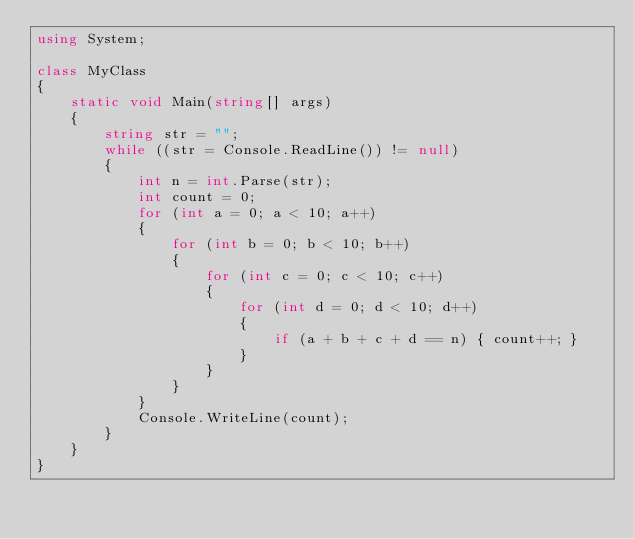<code> <loc_0><loc_0><loc_500><loc_500><_C#_>using System;

class MyClass
{
    static void Main(string[] args)
    {
        string str = "";
        while ((str = Console.ReadLine()) != null)
        {
            int n = int.Parse(str);
            int count = 0;
            for (int a = 0; a < 10; a++)
            {
                for (int b = 0; b < 10; b++)
                {
                    for (int c = 0; c < 10; c++)
                    {
                        for (int d = 0; d < 10; d++)
                        {
                            if (a + b + c + d == n) { count++; }
                        }
                    }
                }
            }
            Console.WriteLine(count);
        }
    }
}
</code> 